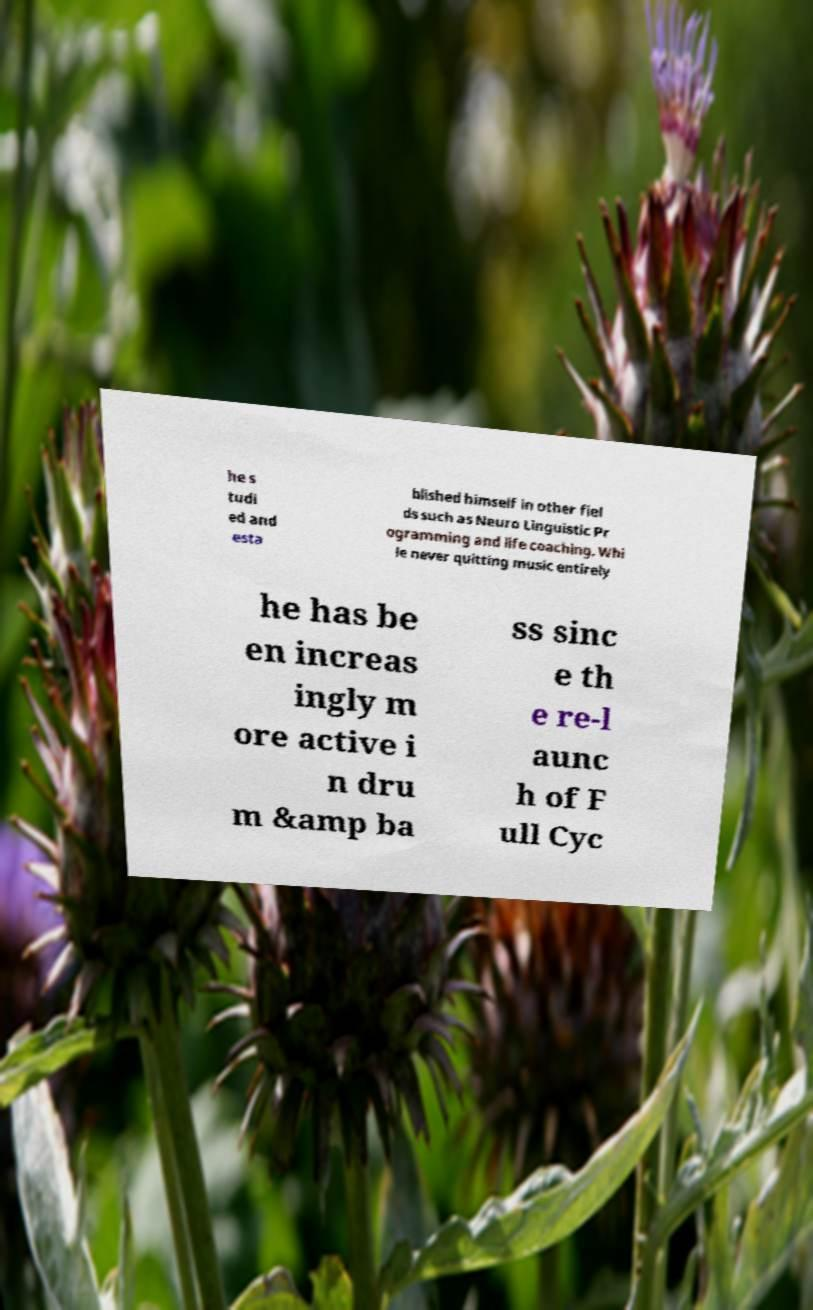Could you assist in decoding the text presented in this image and type it out clearly? he s tudi ed and esta blished himself in other fiel ds such as Neuro Linguistic Pr ogramming and life coaching. Whi le never quitting music entirely he has be en increas ingly m ore active i n dru m &amp ba ss sinc e th e re-l aunc h of F ull Cyc 